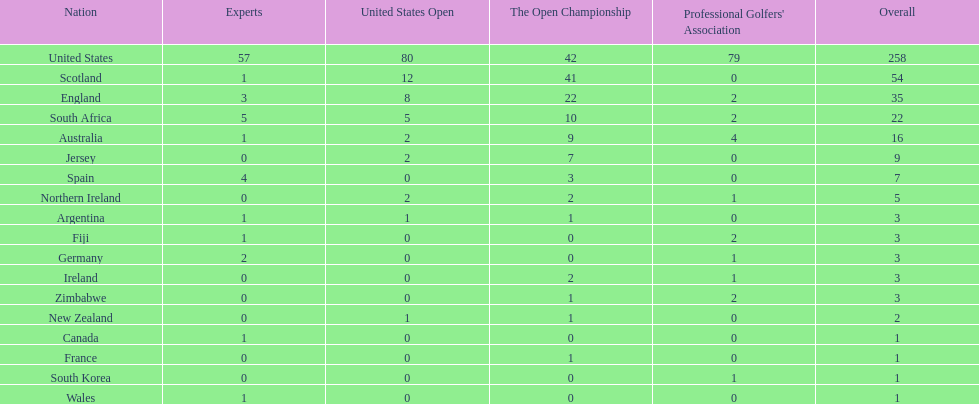Combined, how many winning golfers does england and wales have in the masters? 4. 